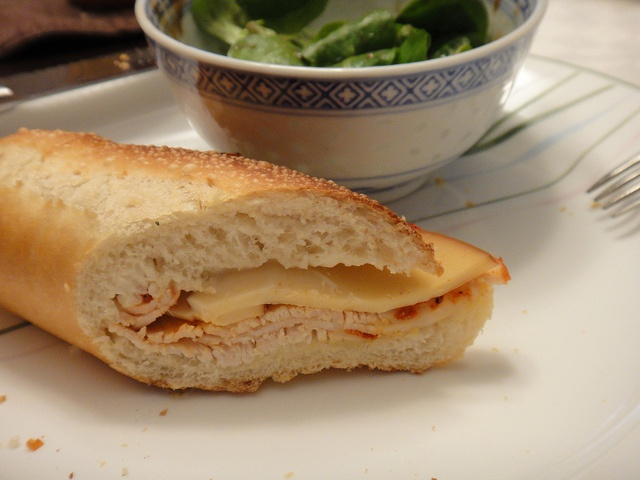Describe the objects in this image and their specific colors. I can see sandwich in brown, tan, and olive tones, bowl in brown, black, olive, and gray tones, and fork in brown, tan, and gray tones in this image. 